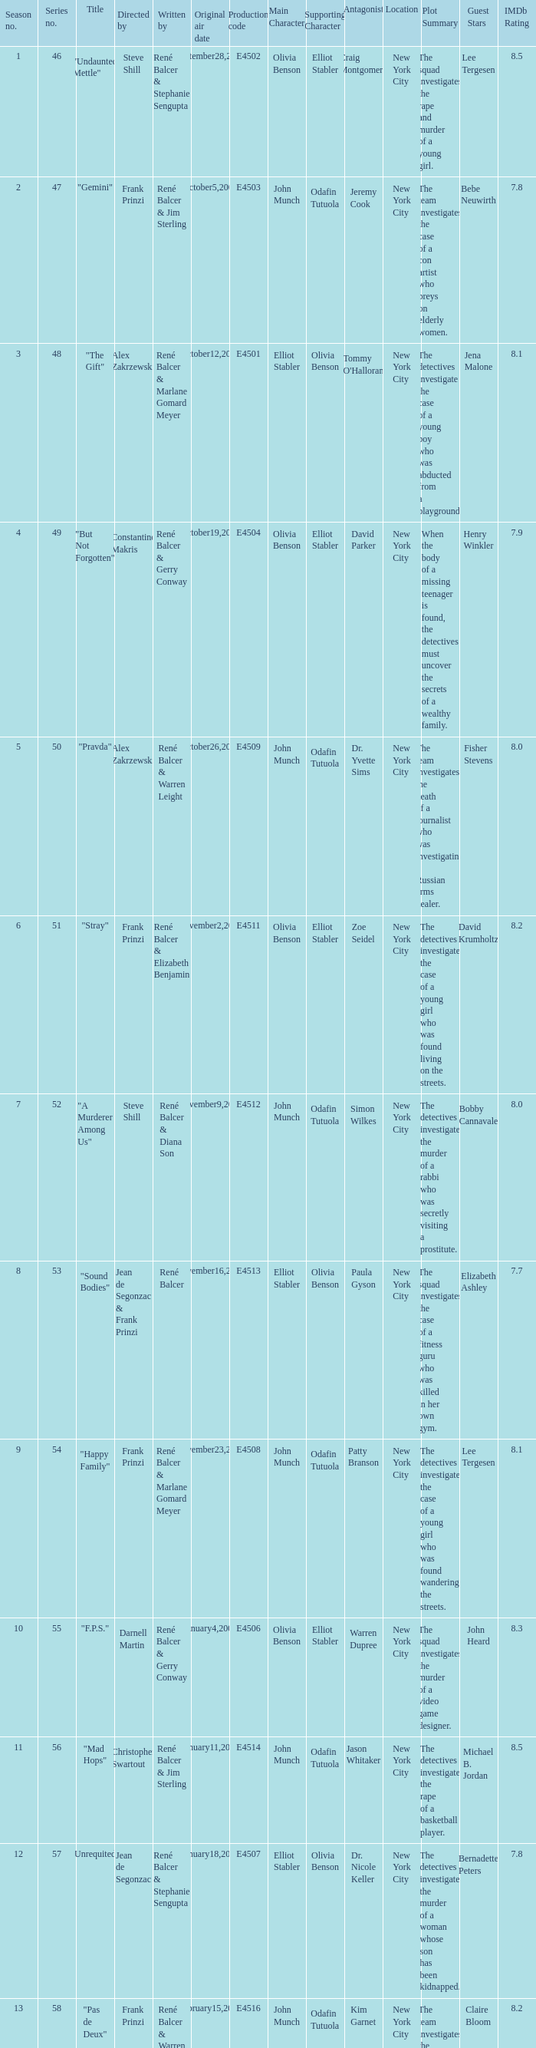Who wrote the episode with e4515 as the production code? René Balcer & Elizabeth Benjamin. 